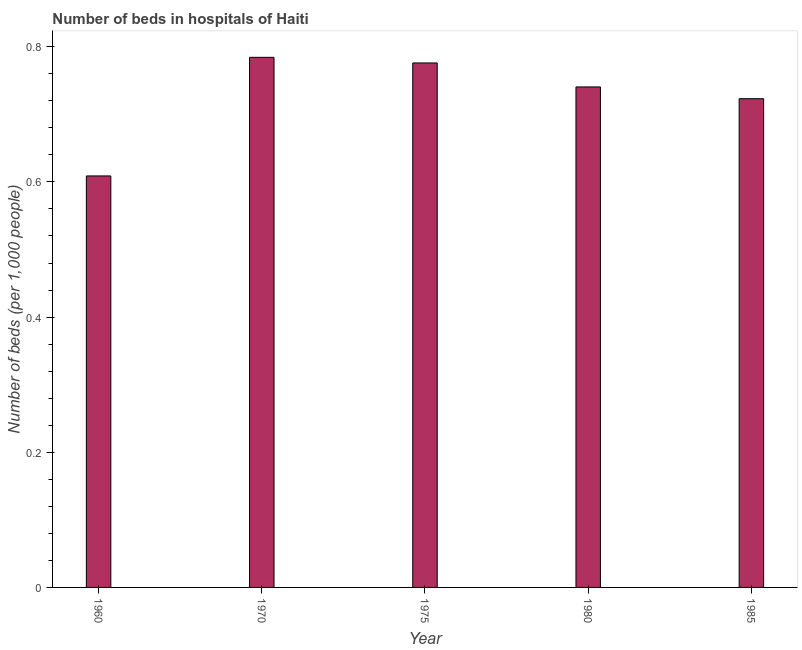What is the title of the graph?
Your answer should be very brief. Number of beds in hospitals of Haiti. What is the label or title of the Y-axis?
Your answer should be compact. Number of beds (per 1,0 people). What is the number of hospital beds in 1985?
Make the answer very short. 0.72. Across all years, what is the maximum number of hospital beds?
Keep it short and to the point. 0.78. Across all years, what is the minimum number of hospital beds?
Provide a short and direct response. 0.61. In which year was the number of hospital beds minimum?
Offer a terse response. 1960. What is the sum of the number of hospital beds?
Provide a succinct answer. 3.63. What is the difference between the number of hospital beds in 1975 and 1985?
Your answer should be compact. 0.05. What is the average number of hospital beds per year?
Give a very brief answer. 0.73. What is the median number of hospital beds?
Provide a succinct answer. 0.74. Do a majority of the years between 1975 and 1980 (inclusive) have number of hospital beds greater than 0.48 %?
Provide a short and direct response. Yes. What is the ratio of the number of hospital beds in 1960 to that in 1975?
Offer a very short reply. 0.79. Is the difference between the number of hospital beds in 1970 and 1985 greater than the difference between any two years?
Provide a succinct answer. No. What is the difference between the highest and the second highest number of hospital beds?
Provide a succinct answer. 0.01. What is the difference between the highest and the lowest number of hospital beds?
Provide a succinct answer. 0.18. How many years are there in the graph?
Ensure brevity in your answer.  5. Are the values on the major ticks of Y-axis written in scientific E-notation?
Offer a terse response. No. What is the Number of beds (per 1,000 people) in 1960?
Offer a terse response. 0.61. What is the Number of beds (per 1,000 people) in 1970?
Provide a succinct answer. 0.78. What is the Number of beds (per 1,000 people) of 1975?
Make the answer very short. 0.78. What is the Number of beds (per 1,000 people) of 1980?
Offer a terse response. 0.74. What is the Number of beds (per 1,000 people) in 1985?
Ensure brevity in your answer.  0.72. What is the difference between the Number of beds (per 1,000 people) in 1960 and 1970?
Keep it short and to the point. -0.18. What is the difference between the Number of beds (per 1,000 people) in 1960 and 1975?
Provide a succinct answer. -0.17. What is the difference between the Number of beds (per 1,000 people) in 1960 and 1980?
Ensure brevity in your answer.  -0.13. What is the difference between the Number of beds (per 1,000 people) in 1960 and 1985?
Your answer should be very brief. -0.11. What is the difference between the Number of beds (per 1,000 people) in 1970 and 1975?
Your answer should be compact. 0.01. What is the difference between the Number of beds (per 1,000 people) in 1970 and 1980?
Your answer should be very brief. 0.04. What is the difference between the Number of beds (per 1,000 people) in 1970 and 1985?
Keep it short and to the point. 0.06. What is the difference between the Number of beds (per 1,000 people) in 1975 and 1980?
Provide a short and direct response. 0.04. What is the difference between the Number of beds (per 1,000 people) in 1975 and 1985?
Your answer should be very brief. 0.05. What is the difference between the Number of beds (per 1,000 people) in 1980 and 1985?
Offer a very short reply. 0.02. What is the ratio of the Number of beds (per 1,000 people) in 1960 to that in 1970?
Offer a very short reply. 0.78. What is the ratio of the Number of beds (per 1,000 people) in 1960 to that in 1975?
Make the answer very short. 0.79. What is the ratio of the Number of beds (per 1,000 people) in 1960 to that in 1980?
Offer a terse response. 0.82. What is the ratio of the Number of beds (per 1,000 people) in 1960 to that in 1985?
Your answer should be very brief. 0.84. What is the ratio of the Number of beds (per 1,000 people) in 1970 to that in 1980?
Offer a very short reply. 1.06. What is the ratio of the Number of beds (per 1,000 people) in 1970 to that in 1985?
Offer a terse response. 1.08. What is the ratio of the Number of beds (per 1,000 people) in 1975 to that in 1980?
Offer a terse response. 1.05. What is the ratio of the Number of beds (per 1,000 people) in 1975 to that in 1985?
Make the answer very short. 1.07. What is the ratio of the Number of beds (per 1,000 people) in 1980 to that in 1985?
Keep it short and to the point. 1.02. 